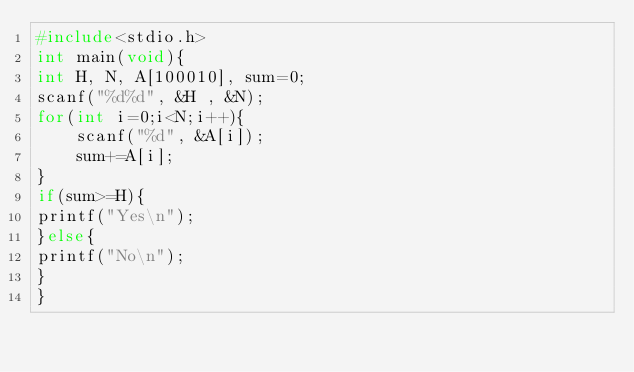<code> <loc_0><loc_0><loc_500><loc_500><_C_>#include<stdio.h>
int main(void){
int H, N, A[100010], sum=0;
scanf("%d%d", &H , &N);
for(int i=0;i<N;i++){
    scanf("%d", &A[i]);
    sum+=A[i];
}
if(sum>=H){
printf("Yes\n");
}else{
printf("No\n");
}
}</code> 